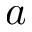<formula> <loc_0><loc_0><loc_500><loc_500>a</formula> 